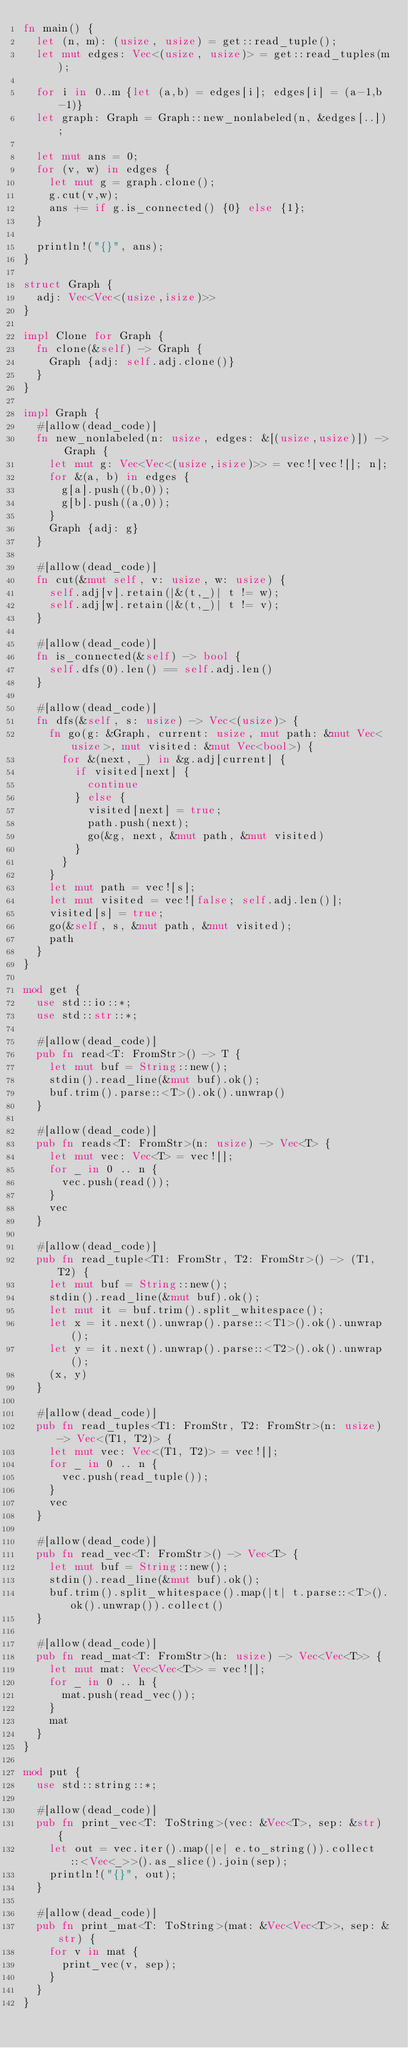<code> <loc_0><loc_0><loc_500><loc_500><_Rust_>fn main() {
  let (n, m): (usize, usize) = get::read_tuple();
  let mut edges: Vec<(usize, usize)> = get::read_tuples(m);

  for i in 0..m {let (a,b) = edges[i]; edges[i] = (a-1,b-1)}
  let graph: Graph = Graph::new_nonlabeled(n, &edges[..]);
  
  let mut ans = 0;
  for (v, w) in edges {
    let mut g = graph.clone();
    g.cut(v,w);
    ans += if g.is_connected() {0} else {1};
  }
  
  println!("{}", ans);
}

struct Graph {
  adj: Vec<Vec<(usize,isize)>>
}

impl Clone for Graph {
  fn clone(&self) -> Graph {
    Graph {adj: self.adj.clone()}
  }
}

impl Graph {
  #[allow(dead_code)]
  fn new_nonlabeled(n: usize, edges: &[(usize,usize)]) -> Graph {
    let mut g: Vec<Vec<(usize,isize)>> = vec![vec![]; n];
    for &(a, b) in edges {
      g[a].push((b,0));
      g[b].push((a,0));
    }
    Graph {adj: g}
  }
  
  #[allow(dead_code)]
  fn cut(&mut self, v: usize, w: usize) {
    self.adj[v].retain(|&(t,_)| t != w);
    self.adj[w].retain(|&(t,_)| t != v);
  }
  
  #[allow(dead_code)]
  fn is_connected(&self) -> bool {
    self.dfs(0).len() == self.adj.len()
  }
  
  #[allow(dead_code)]
  fn dfs(&self, s: usize) -> Vec<(usize)> {
    fn go(g: &Graph, current: usize, mut path: &mut Vec<usize>, mut visited: &mut Vec<bool>) {
      for &(next, _) in &g.adj[current] {
        if visited[next] {
          continue
        } else {
          visited[next] = true;
          path.push(next);
          go(&g, next, &mut path, &mut visited)
        }
      }
    }
    let mut path = vec![s];
    let mut visited = vec![false; self.adj.len()];
    visited[s] = true;
    go(&self, s, &mut path, &mut visited);
    path
  }
}

mod get {
  use std::io::*;
  use std::str::*;

  #[allow(dead_code)]
  pub fn read<T: FromStr>() -> T {
    let mut buf = String::new();
    stdin().read_line(&mut buf).ok();
    buf.trim().parse::<T>().ok().unwrap()
  }

  #[allow(dead_code)]
  pub fn reads<T: FromStr>(n: usize) -> Vec<T> {
    let mut vec: Vec<T> = vec![];
    for _ in 0 .. n {
      vec.push(read());
    }
    vec
  }

  #[allow(dead_code)]
  pub fn read_tuple<T1: FromStr, T2: FromStr>() -> (T1, T2) {
    let mut buf = String::new();
    stdin().read_line(&mut buf).ok();
    let mut it = buf.trim().split_whitespace();
    let x = it.next().unwrap().parse::<T1>().ok().unwrap();
    let y = it.next().unwrap().parse::<T2>().ok().unwrap();
    (x, y)
  }

  #[allow(dead_code)]
  pub fn read_tuples<T1: FromStr, T2: FromStr>(n: usize) -> Vec<(T1, T2)> {
    let mut vec: Vec<(T1, T2)> = vec![];
    for _ in 0 .. n {
      vec.push(read_tuple());
    }
    vec
  }

  #[allow(dead_code)]
  pub fn read_vec<T: FromStr>() -> Vec<T> {
    let mut buf = String::new();
    stdin().read_line(&mut buf).ok();
    buf.trim().split_whitespace().map(|t| t.parse::<T>().ok().unwrap()).collect()
  }

  #[allow(dead_code)]
  pub fn read_mat<T: FromStr>(h: usize) -> Vec<Vec<T>> {
    let mut mat: Vec<Vec<T>> = vec![];
    for _ in 0 .. h {
      mat.push(read_vec());
    }
    mat
  }
}

mod put {
  use std::string::*;

  #[allow(dead_code)]
  pub fn print_vec<T: ToString>(vec: &Vec<T>, sep: &str) {
    let out = vec.iter().map(|e| e.to_string()).collect::<Vec<_>>().as_slice().join(sep);
    println!("{}", out);
  }

  #[allow(dead_code)]
  pub fn print_mat<T: ToString>(mat: &Vec<Vec<T>>, sep: &str) {
    for v in mat {
      print_vec(v, sep);
    }
  }
}</code> 